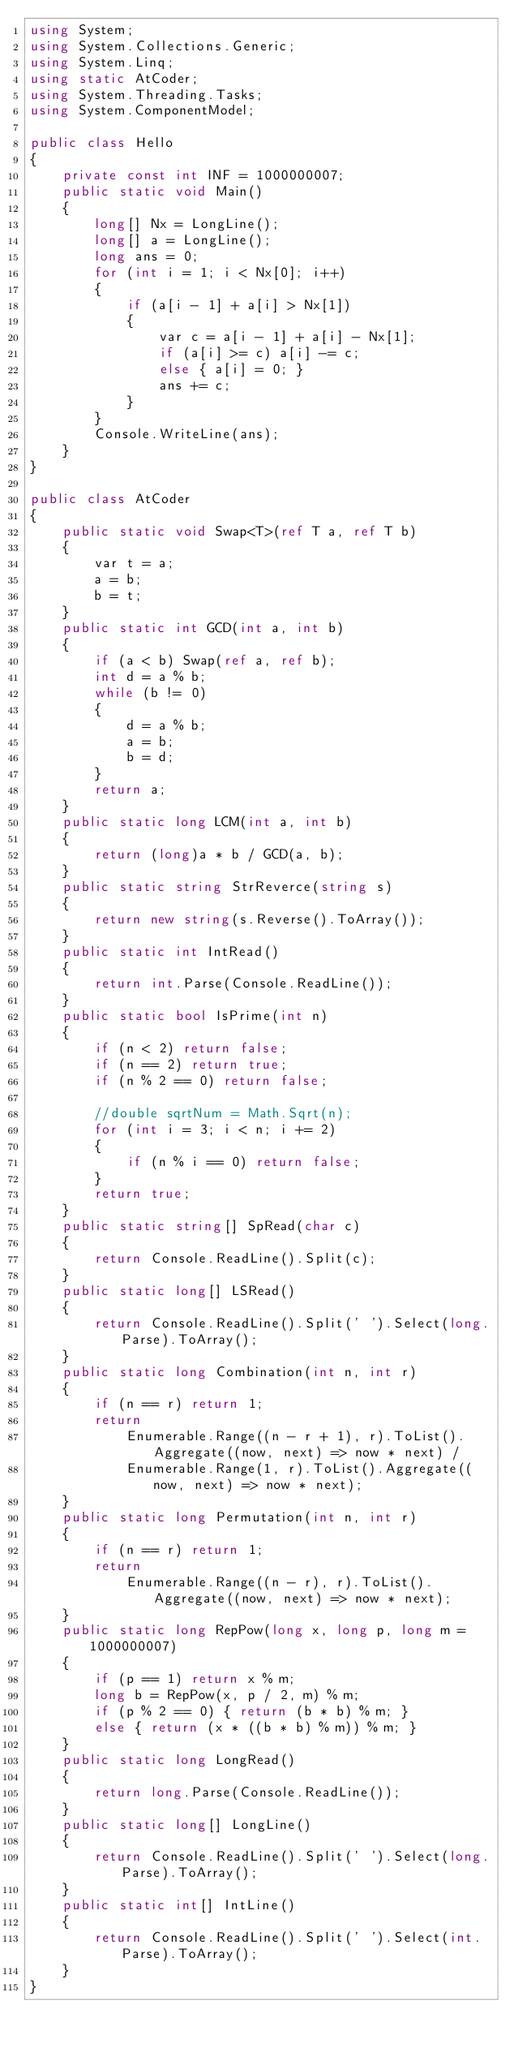<code> <loc_0><loc_0><loc_500><loc_500><_C#_>using System;
using System.Collections.Generic;
using System.Linq;
using static AtCoder;
using System.Threading.Tasks;
using System.ComponentModel;

public class Hello
{
    private const int INF = 1000000007;
    public static void Main()
    {
        long[] Nx = LongLine();
        long[] a = LongLine();
        long ans = 0;
        for (int i = 1; i < Nx[0]; i++)
        {
            if (a[i - 1] + a[i] > Nx[1])
            {
                var c = a[i - 1] + a[i] - Nx[1];
                if (a[i] >= c) a[i] -= c;
                else { a[i] = 0; }
                ans += c;
            }
        }
        Console.WriteLine(ans);
    }
}

public class AtCoder
{
    public static void Swap<T>(ref T a, ref T b)
    {
        var t = a;
        a = b;
        b = t;
    }
    public static int GCD(int a, int b)
    {
        if (a < b) Swap(ref a, ref b);
        int d = a % b;
        while (b != 0)
        {
            d = a % b;
            a = b;
            b = d;
        }
        return a;
    }
    public static long LCM(int a, int b)
    {
        return (long)a * b / GCD(a, b);
    }
    public static string StrReverce(string s)
    {
        return new string(s.Reverse().ToArray());
    }
    public static int IntRead()
    {
        return int.Parse(Console.ReadLine());
    }
    public static bool IsPrime(int n)
    {
        if (n < 2) return false;
        if (n == 2) return true;
        if (n % 2 == 0) return false;

        //double sqrtNum = Math.Sqrt(n);
        for (int i = 3; i < n; i += 2)
        {
            if (n % i == 0) return false;
        }
        return true;
    }
    public static string[] SpRead(char c)
    {
        return Console.ReadLine().Split(c);
    }
    public static long[] LSRead()
    {
        return Console.ReadLine().Split(' ').Select(long.Parse).ToArray();
    }
    public static long Combination(int n, int r)
    {
        if (n == r) return 1;
        return
            Enumerable.Range((n - r + 1), r).ToList().Aggregate((now, next) => now * next) /
            Enumerable.Range(1, r).ToList().Aggregate((now, next) => now * next);
    }
    public static long Permutation(int n, int r)
    {
        if (n == r) return 1;
        return
            Enumerable.Range((n - r), r).ToList().Aggregate((now, next) => now * next);
    }
    public static long RepPow(long x, long p, long m = 1000000007)
    {
        if (p == 1) return x % m;
        long b = RepPow(x, p / 2, m) % m;
        if (p % 2 == 0) { return (b * b) % m; }
        else { return (x * ((b * b) % m)) % m; }
    }
    public static long LongRead()
    {
        return long.Parse(Console.ReadLine());
    }
    public static long[] LongLine()
    {
        return Console.ReadLine().Split(' ').Select(long.Parse).ToArray();
    }
    public static int[] IntLine()
    {
        return Console.ReadLine().Split(' ').Select(int.Parse).ToArray();
    }
}
</code> 